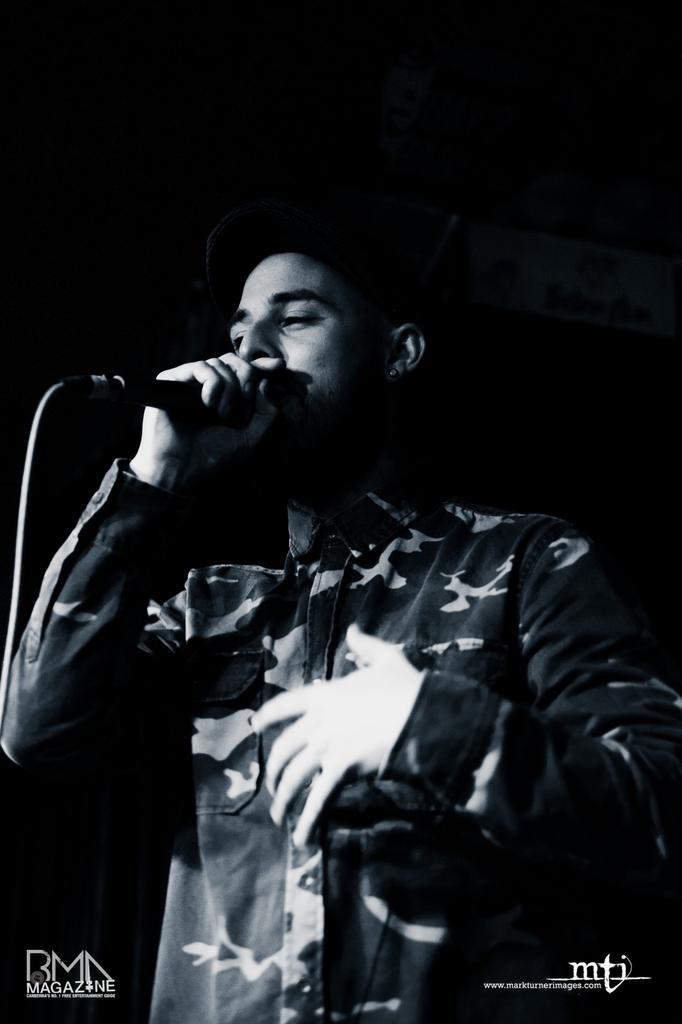How would you summarize this image in a sentence or two? In this picture we can see one person is standing and singing with the help of a microphone. 